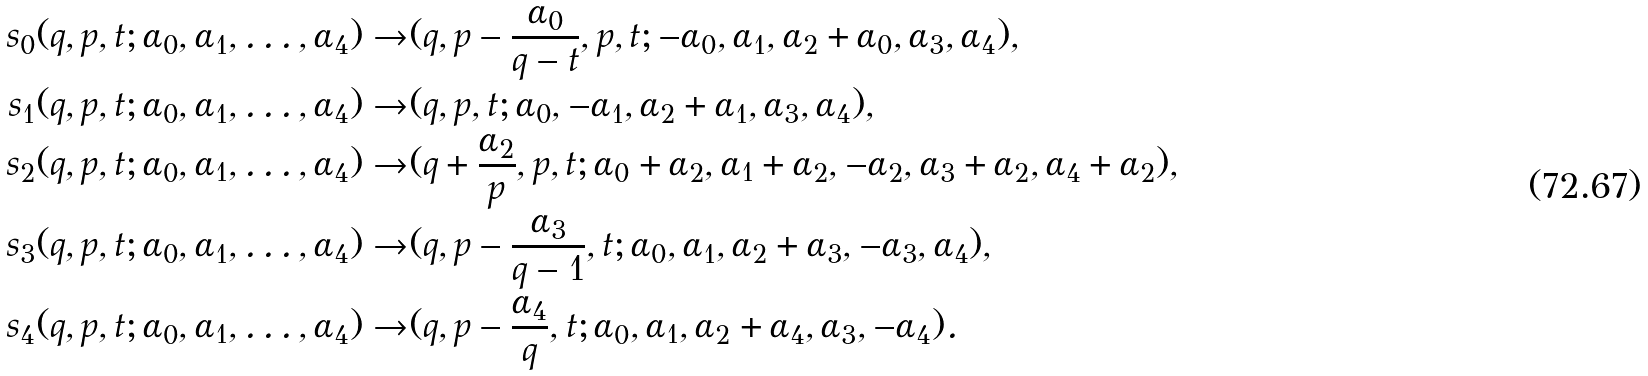<formula> <loc_0><loc_0><loc_500><loc_500>s _ { 0 } ( q , p , t ; \alpha _ { 0 } , \alpha _ { 1 } , \dots , \alpha _ { 4 } ) \rightarrow & ( q , p - \frac { \alpha _ { 0 } } { q - t } , p , t ; - \alpha _ { 0 } , \alpha _ { 1 } , \alpha _ { 2 } + \alpha _ { 0 } , \alpha _ { 3 } , \alpha _ { 4 } ) , \\ s _ { 1 } ( q , p , t ; \alpha _ { 0 } , \alpha _ { 1 } , \dots , \alpha _ { 4 } ) \rightarrow & ( q , p , t ; \alpha _ { 0 } , - \alpha _ { 1 } , \alpha _ { 2 } + \alpha _ { 1 } , \alpha _ { 3 } , \alpha _ { 4 } ) , \\ s _ { 2 } ( q , p , t ; \alpha _ { 0 } , \alpha _ { 1 } , \dots , \alpha _ { 4 } ) \rightarrow & ( q + \frac { \alpha _ { 2 } } { p } , p , t ; \alpha _ { 0 } + \alpha _ { 2 } , \alpha _ { 1 } + \alpha _ { 2 } , - \alpha _ { 2 } , \alpha _ { 3 } + \alpha _ { 2 } , \alpha _ { 4 } + \alpha _ { 2 } ) , \\ s _ { 3 } ( q , p , t ; \alpha _ { 0 } , \alpha _ { 1 } , \dots , \alpha _ { 4 } ) \rightarrow & ( q , p - \frac { \alpha _ { 3 } } { q - 1 } , t ; \alpha _ { 0 } , \alpha _ { 1 } , \alpha _ { 2 } + \alpha _ { 3 } , - \alpha _ { 3 } , \alpha _ { 4 } ) , \\ s _ { 4 } ( q , p , t ; \alpha _ { 0 } , \alpha _ { 1 } , \dots , \alpha _ { 4 } ) \rightarrow & ( q , p - \frac { \alpha _ { 4 } } { q } , t ; \alpha _ { 0 } , \alpha _ { 1 } , \alpha _ { 2 } + \alpha _ { 4 } , \alpha _ { 3 } , - \alpha _ { 4 } ) .</formula> 